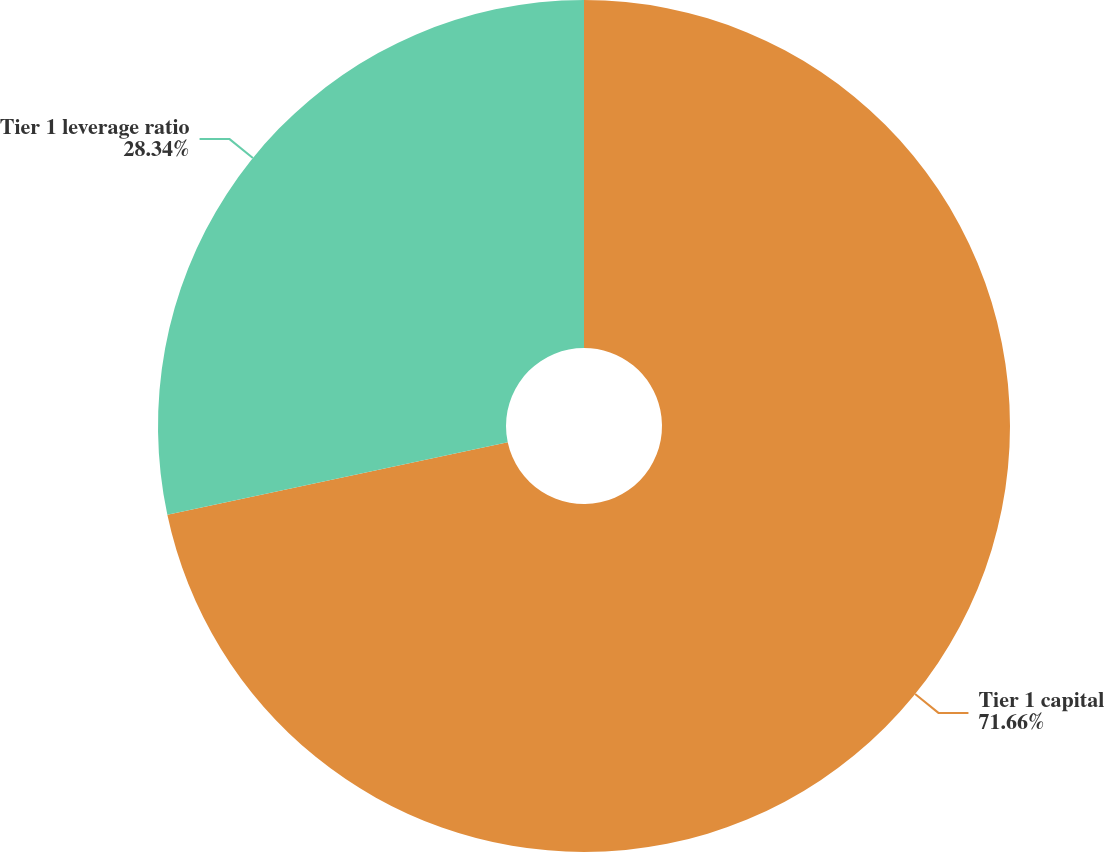Convert chart. <chart><loc_0><loc_0><loc_500><loc_500><pie_chart><fcel>Tier 1 capital<fcel>Tier 1 leverage ratio<nl><fcel>71.66%<fcel>28.34%<nl></chart> 